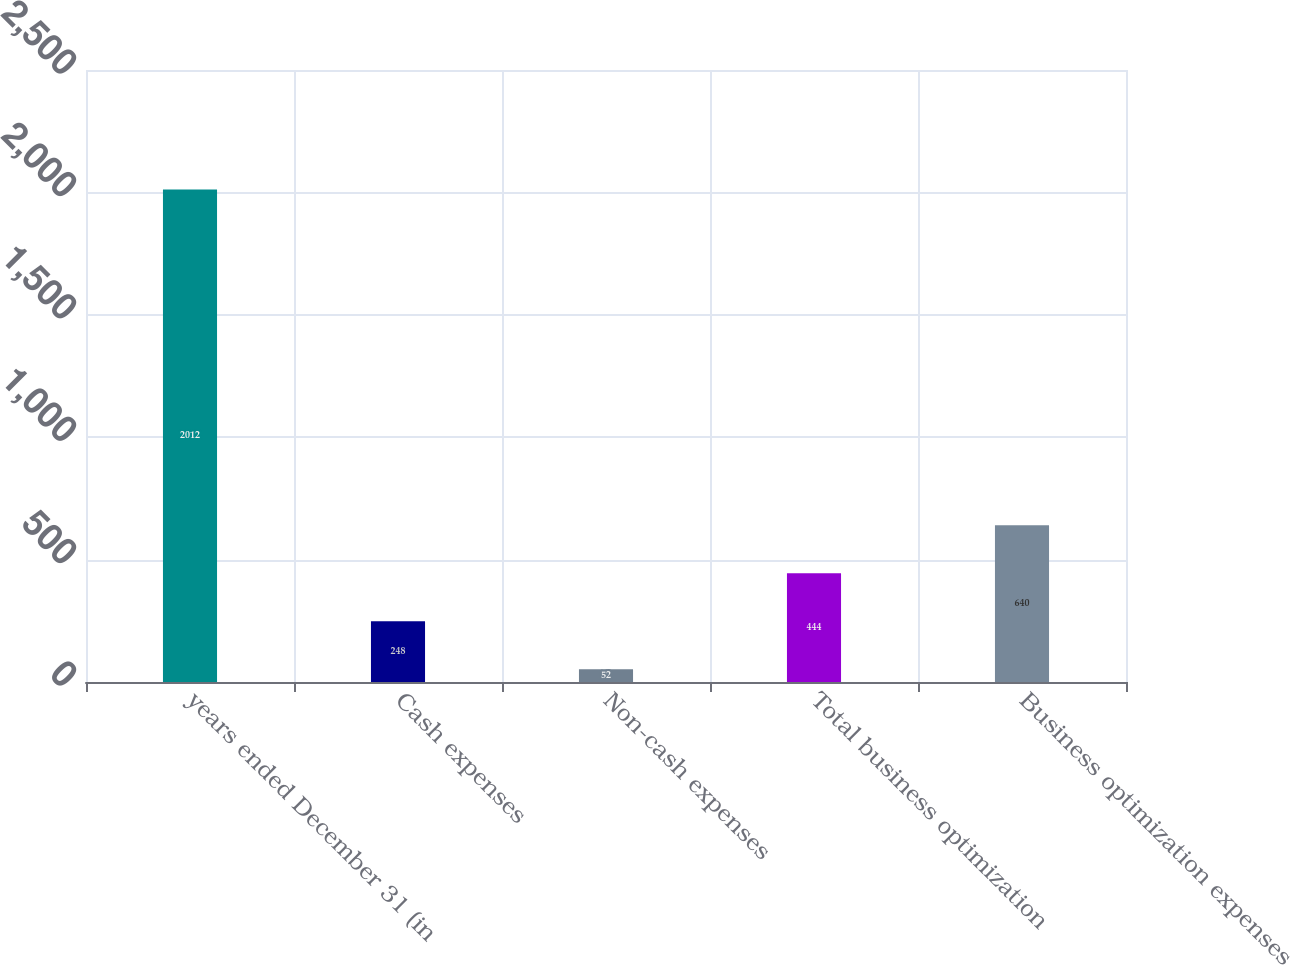Convert chart to OTSL. <chart><loc_0><loc_0><loc_500><loc_500><bar_chart><fcel>years ended December 31 (in<fcel>Cash expenses<fcel>Non-cash expenses<fcel>Total business optimization<fcel>Business optimization expenses<nl><fcel>2012<fcel>248<fcel>52<fcel>444<fcel>640<nl></chart> 